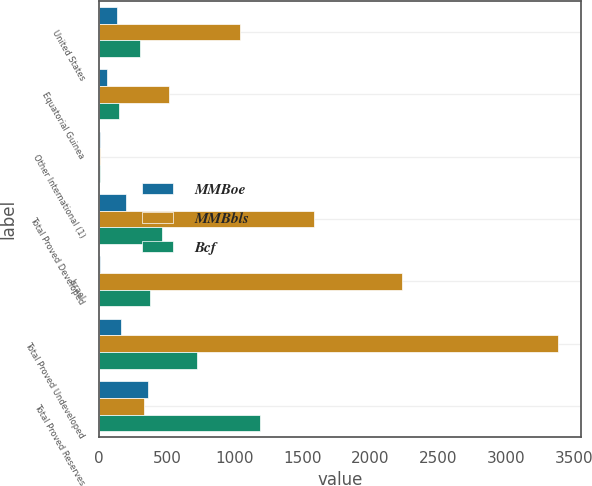<chart> <loc_0><loc_0><loc_500><loc_500><stacked_bar_chart><ecel><fcel>United States<fcel>Equatorial Guinea<fcel>Other International (1)<fcel>Total Proved Developed<fcel>Israel<fcel>Total Proved Undeveloped<fcel>Total Proved Reserves<nl><fcel>MMBoe<fcel>130<fcel>60<fcel>8<fcel>198<fcel>3<fcel>159<fcel>357<nl><fcel>MMBbls<fcel>1042<fcel>514<fcel>8<fcel>1582<fcel>2232<fcel>3382<fcel>330<nl><fcel>Bcf<fcel>303<fcel>146<fcel>9<fcel>461<fcel>375<fcel>723<fcel>1184<nl></chart> 